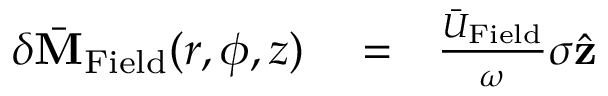<formula> <loc_0><loc_0><loc_500><loc_500>\begin{array} { r l r } { \delta \bar { M } _ { F i e l d } ( r , \phi , z ) } & = } & { \frac { \bar { U } _ { F i e l d } } { \omega } \sigma \hat { z } } \end{array}</formula> 